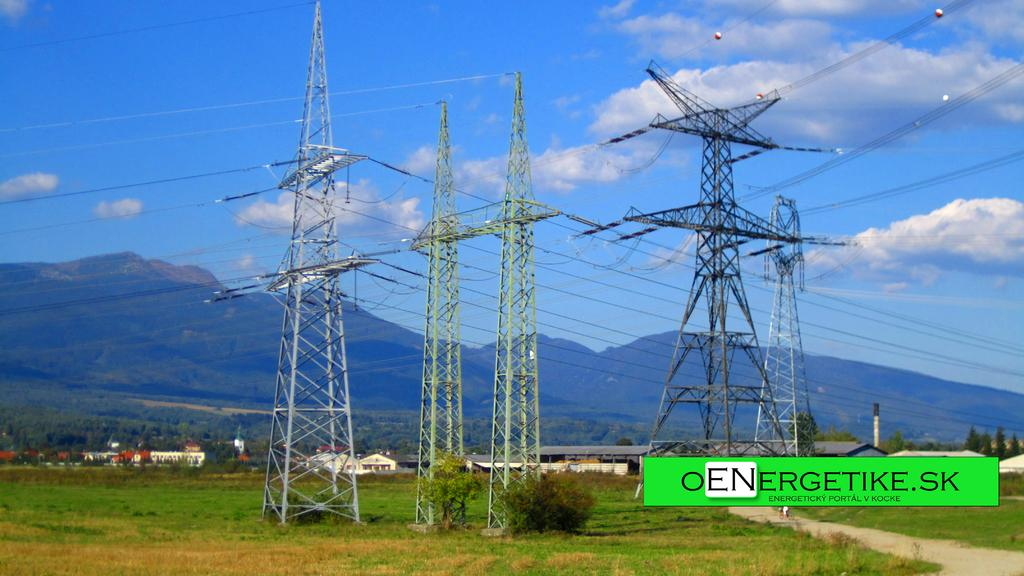What structures are visible in the image? There are towers in the image. What can be seen in the background of the image? There are houses, trees, and hills in the background of the image. How many babies are playing with a rake in the image? There are no babies or rakes present in the image. 